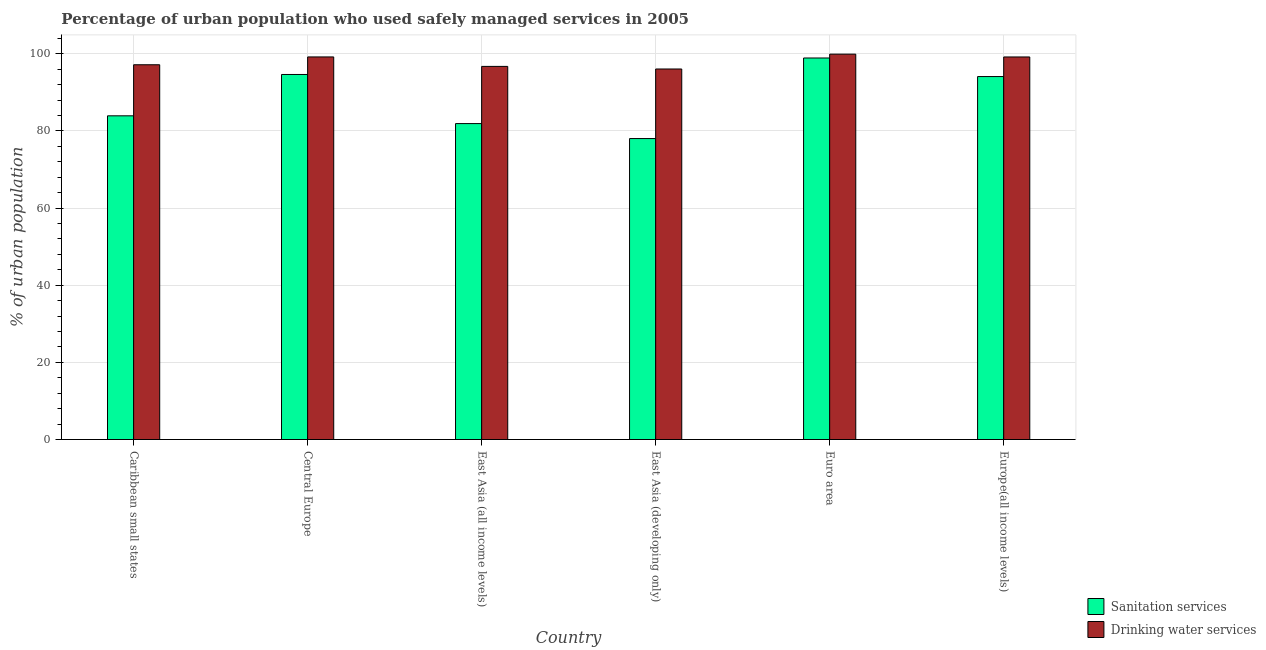Are the number of bars per tick equal to the number of legend labels?
Make the answer very short. Yes. How many bars are there on the 3rd tick from the left?
Provide a succinct answer. 2. How many bars are there on the 5th tick from the right?
Your answer should be very brief. 2. What is the label of the 2nd group of bars from the left?
Your answer should be compact. Central Europe. In how many cases, is the number of bars for a given country not equal to the number of legend labels?
Offer a terse response. 0. What is the percentage of urban population who used drinking water services in Caribbean small states?
Provide a succinct answer. 97.16. Across all countries, what is the maximum percentage of urban population who used sanitation services?
Keep it short and to the point. 98.92. Across all countries, what is the minimum percentage of urban population who used drinking water services?
Give a very brief answer. 96.07. In which country was the percentage of urban population who used drinking water services maximum?
Ensure brevity in your answer.  Euro area. In which country was the percentage of urban population who used sanitation services minimum?
Provide a succinct answer. East Asia (developing only). What is the total percentage of urban population who used drinking water services in the graph?
Your answer should be compact. 588.27. What is the difference between the percentage of urban population who used drinking water services in Central Europe and that in Euro area?
Keep it short and to the point. -0.72. What is the difference between the percentage of urban population who used sanitation services in Europe(all income levels) and the percentage of urban population who used drinking water services in Central Europe?
Your answer should be very brief. -5.09. What is the average percentage of urban population who used sanitation services per country?
Provide a succinct answer. 88.59. What is the difference between the percentage of urban population who used drinking water services and percentage of urban population who used sanitation services in Euro area?
Your answer should be compact. 1. What is the ratio of the percentage of urban population who used drinking water services in Central Europe to that in Europe(all income levels)?
Keep it short and to the point. 1. What is the difference between the highest and the second highest percentage of urban population who used drinking water services?
Offer a very short reply. 0.72. What is the difference between the highest and the lowest percentage of urban population who used drinking water services?
Ensure brevity in your answer.  3.85. What does the 2nd bar from the left in East Asia (all income levels) represents?
Ensure brevity in your answer.  Drinking water services. What does the 2nd bar from the right in East Asia (all income levels) represents?
Make the answer very short. Sanitation services. Are all the bars in the graph horizontal?
Give a very brief answer. No. How many countries are there in the graph?
Make the answer very short. 6. Does the graph contain any zero values?
Your answer should be very brief. No. Does the graph contain grids?
Offer a very short reply. Yes. Where does the legend appear in the graph?
Your response must be concise. Bottom right. What is the title of the graph?
Make the answer very short. Percentage of urban population who used safely managed services in 2005. What is the label or title of the Y-axis?
Offer a very short reply. % of urban population. What is the % of urban population in Sanitation services in Caribbean small states?
Give a very brief answer. 83.93. What is the % of urban population of Drinking water services in Caribbean small states?
Your response must be concise. 97.16. What is the % of urban population in Sanitation services in Central Europe?
Your response must be concise. 94.65. What is the % of urban population of Drinking water services in Central Europe?
Ensure brevity in your answer.  99.19. What is the % of urban population in Sanitation services in East Asia (all income levels)?
Provide a succinct answer. 81.91. What is the % of urban population in Drinking water services in East Asia (all income levels)?
Give a very brief answer. 96.74. What is the % of urban population of Sanitation services in East Asia (developing only)?
Provide a short and direct response. 78.03. What is the % of urban population in Drinking water services in East Asia (developing only)?
Provide a succinct answer. 96.07. What is the % of urban population in Sanitation services in Euro area?
Your answer should be compact. 98.92. What is the % of urban population of Drinking water services in Euro area?
Ensure brevity in your answer.  99.92. What is the % of urban population of Sanitation services in Europe(all income levels)?
Your answer should be compact. 94.11. What is the % of urban population of Drinking water services in Europe(all income levels)?
Your answer should be very brief. 99.19. Across all countries, what is the maximum % of urban population of Sanitation services?
Ensure brevity in your answer.  98.92. Across all countries, what is the maximum % of urban population in Drinking water services?
Ensure brevity in your answer.  99.92. Across all countries, what is the minimum % of urban population in Sanitation services?
Offer a terse response. 78.03. Across all countries, what is the minimum % of urban population of Drinking water services?
Offer a very short reply. 96.07. What is the total % of urban population in Sanitation services in the graph?
Your response must be concise. 531.54. What is the total % of urban population of Drinking water services in the graph?
Keep it short and to the point. 588.27. What is the difference between the % of urban population in Sanitation services in Caribbean small states and that in Central Europe?
Offer a very short reply. -10.72. What is the difference between the % of urban population of Drinking water services in Caribbean small states and that in Central Europe?
Provide a succinct answer. -2.03. What is the difference between the % of urban population in Sanitation services in Caribbean small states and that in East Asia (all income levels)?
Your answer should be very brief. 2.01. What is the difference between the % of urban population in Drinking water services in Caribbean small states and that in East Asia (all income levels)?
Keep it short and to the point. 0.43. What is the difference between the % of urban population in Sanitation services in Caribbean small states and that in East Asia (developing only)?
Your response must be concise. 5.9. What is the difference between the % of urban population of Drinking water services in Caribbean small states and that in East Asia (developing only)?
Keep it short and to the point. 1.1. What is the difference between the % of urban population in Sanitation services in Caribbean small states and that in Euro area?
Make the answer very short. -14.99. What is the difference between the % of urban population of Drinking water services in Caribbean small states and that in Euro area?
Make the answer very short. -2.75. What is the difference between the % of urban population of Sanitation services in Caribbean small states and that in Europe(all income levels)?
Give a very brief answer. -10.18. What is the difference between the % of urban population in Drinking water services in Caribbean small states and that in Europe(all income levels)?
Your answer should be very brief. -2.02. What is the difference between the % of urban population in Sanitation services in Central Europe and that in East Asia (all income levels)?
Give a very brief answer. 12.73. What is the difference between the % of urban population in Drinking water services in Central Europe and that in East Asia (all income levels)?
Keep it short and to the point. 2.45. What is the difference between the % of urban population in Sanitation services in Central Europe and that in East Asia (developing only)?
Give a very brief answer. 16.62. What is the difference between the % of urban population in Drinking water services in Central Europe and that in East Asia (developing only)?
Give a very brief answer. 3.12. What is the difference between the % of urban population in Sanitation services in Central Europe and that in Euro area?
Your answer should be very brief. -4.27. What is the difference between the % of urban population of Drinking water services in Central Europe and that in Euro area?
Provide a succinct answer. -0.72. What is the difference between the % of urban population in Sanitation services in Central Europe and that in Europe(all income levels)?
Your answer should be compact. 0.54. What is the difference between the % of urban population in Drinking water services in Central Europe and that in Europe(all income levels)?
Keep it short and to the point. 0.01. What is the difference between the % of urban population in Sanitation services in East Asia (all income levels) and that in East Asia (developing only)?
Provide a short and direct response. 3.88. What is the difference between the % of urban population in Drinking water services in East Asia (all income levels) and that in East Asia (developing only)?
Offer a terse response. 0.67. What is the difference between the % of urban population in Sanitation services in East Asia (all income levels) and that in Euro area?
Your answer should be compact. -17. What is the difference between the % of urban population of Drinking water services in East Asia (all income levels) and that in Euro area?
Keep it short and to the point. -3.18. What is the difference between the % of urban population of Sanitation services in East Asia (all income levels) and that in Europe(all income levels)?
Make the answer very short. -12.19. What is the difference between the % of urban population in Drinking water services in East Asia (all income levels) and that in Europe(all income levels)?
Your answer should be compact. -2.45. What is the difference between the % of urban population of Sanitation services in East Asia (developing only) and that in Euro area?
Keep it short and to the point. -20.89. What is the difference between the % of urban population of Drinking water services in East Asia (developing only) and that in Euro area?
Keep it short and to the point. -3.85. What is the difference between the % of urban population of Sanitation services in East Asia (developing only) and that in Europe(all income levels)?
Your answer should be very brief. -16.08. What is the difference between the % of urban population of Drinking water services in East Asia (developing only) and that in Europe(all income levels)?
Provide a succinct answer. -3.12. What is the difference between the % of urban population of Sanitation services in Euro area and that in Europe(all income levels)?
Your answer should be very brief. 4.81. What is the difference between the % of urban population in Drinking water services in Euro area and that in Europe(all income levels)?
Offer a terse response. 0.73. What is the difference between the % of urban population of Sanitation services in Caribbean small states and the % of urban population of Drinking water services in Central Europe?
Give a very brief answer. -15.27. What is the difference between the % of urban population in Sanitation services in Caribbean small states and the % of urban population in Drinking water services in East Asia (all income levels)?
Make the answer very short. -12.81. What is the difference between the % of urban population in Sanitation services in Caribbean small states and the % of urban population in Drinking water services in East Asia (developing only)?
Offer a terse response. -12.14. What is the difference between the % of urban population of Sanitation services in Caribbean small states and the % of urban population of Drinking water services in Euro area?
Give a very brief answer. -15.99. What is the difference between the % of urban population of Sanitation services in Caribbean small states and the % of urban population of Drinking water services in Europe(all income levels)?
Offer a very short reply. -15.26. What is the difference between the % of urban population of Sanitation services in Central Europe and the % of urban population of Drinking water services in East Asia (all income levels)?
Your response must be concise. -2.09. What is the difference between the % of urban population in Sanitation services in Central Europe and the % of urban population in Drinking water services in East Asia (developing only)?
Keep it short and to the point. -1.42. What is the difference between the % of urban population of Sanitation services in Central Europe and the % of urban population of Drinking water services in Euro area?
Keep it short and to the point. -5.27. What is the difference between the % of urban population in Sanitation services in Central Europe and the % of urban population in Drinking water services in Europe(all income levels)?
Your response must be concise. -4.54. What is the difference between the % of urban population of Sanitation services in East Asia (all income levels) and the % of urban population of Drinking water services in East Asia (developing only)?
Your response must be concise. -14.16. What is the difference between the % of urban population of Sanitation services in East Asia (all income levels) and the % of urban population of Drinking water services in Euro area?
Your response must be concise. -18. What is the difference between the % of urban population of Sanitation services in East Asia (all income levels) and the % of urban population of Drinking water services in Europe(all income levels)?
Your answer should be very brief. -17.27. What is the difference between the % of urban population of Sanitation services in East Asia (developing only) and the % of urban population of Drinking water services in Euro area?
Make the answer very short. -21.89. What is the difference between the % of urban population in Sanitation services in East Asia (developing only) and the % of urban population in Drinking water services in Europe(all income levels)?
Provide a short and direct response. -21.16. What is the difference between the % of urban population in Sanitation services in Euro area and the % of urban population in Drinking water services in Europe(all income levels)?
Your response must be concise. -0.27. What is the average % of urban population of Sanitation services per country?
Your response must be concise. 88.59. What is the average % of urban population of Drinking water services per country?
Ensure brevity in your answer.  98.04. What is the difference between the % of urban population of Sanitation services and % of urban population of Drinking water services in Caribbean small states?
Keep it short and to the point. -13.24. What is the difference between the % of urban population in Sanitation services and % of urban population in Drinking water services in Central Europe?
Make the answer very short. -4.55. What is the difference between the % of urban population in Sanitation services and % of urban population in Drinking water services in East Asia (all income levels)?
Provide a succinct answer. -14.83. What is the difference between the % of urban population of Sanitation services and % of urban population of Drinking water services in East Asia (developing only)?
Give a very brief answer. -18.04. What is the difference between the % of urban population of Sanitation services and % of urban population of Drinking water services in Euro area?
Ensure brevity in your answer.  -1. What is the difference between the % of urban population of Sanitation services and % of urban population of Drinking water services in Europe(all income levels)?
Your answer should be very brief. -5.08. What is the ratio of the % of urban population in Sanitation services in Caribbean small states to that in Central Europe?
Provide a succinct answer. 0.89. What is the ratio of the % of urban population in Drinking water services in Caribbean small states to that in Central Europe?
Offer a very short reply. 0.98. What is the ratio of the % of urban population of Sanitation services in Caribbean small states to that in East Asia (all income levels)?
Your answer should be very brief. 1.02. What is the ratio of the % of urban population of Drinking water services in Caribbean small states to that in East Asia (all income levels)?
Provide a short and direct response. 1. What is the ratio of the % of urban population of Sanitation services in Caribbean small states to that in East Asia (developing only)?
Ensure brevity in your answer.  1.08. What is the ratio of the % of urban population in Drinking water services in Caribbean small states to that in East Asia (developing only)?
Keep it short and to the point. 1.01. What is the ratio of the % of urban population of Sanitation services in Caribbean small states to that in Euro area?
Provide a short and direct response. 0.85. What is the ratio of the % of urban population of Drinking water services in Caribbean small states to that in Euro area?
Your answer should be compact. 0.97. What is the ratio of the % of urban population of Sanitation services in Caribbean small states to that in Europe(all income levels)?
Make the answer very short. 0.89. What is the ratio of the % of urban population of Drinking water services in Caribbean small states to that in Europe(all income levels)?
Give a very brief answer. 0.98. What is the ratio of the % of urban population in Sanitation services in Central Europe to that in East Asia (all income levels)?
Keep it short and to the point. 1.16. What is the ratio of the % of urban population in Drinking water services in Central Europe to that in East Asia (all income levels)?
Ensure brevity in your answer.  1.03. What is the ratio of the % of urban population in Sanitation services in Central Europe to that in East Asia (developing only)?
Your answer should be compact. 1.21. What is the ratio of the % of urban population in Drinking water services in Central Europe to that in East Asia (developing only)?
Your answer should be very brief. 1.03. What is the ratio of the % of urban population of Sanitation services in Central Europe to that in Euro area?
Provide a short and direct response. 0.96. What is the ratio of the % of urban population of Drinking water services in Central Europe to that in Euro area?
Ensure brevity in your answer.  0.99. What is the ratio of the % of urban population of Drinking water services in Central Europe to that in Europe(all income levels)?
Your response must be concise. 1. What is the ratio of the % of urban population in Sanitation services in East Asia (all income levels) to that in East Asia (developing only)?
Your answer should be compact. 1.05. What is the ratio of the % of urban population in Sanitation services in East Asia (all income levels) to that in Euro area?
Offer a terse response. 0.83. What is the ratio of the % of urban population of Drinking water services in East Asia (all income levels) to that in Euro area?
Give a very brief answer. 0.97. What is the ratio of the % of urban population in Sanitation services in East Asia (all income levels) to that in Europe(all income levels)?
Your answer should be compact. 0.87. What is the ratio of the % of urban population of Drinking water services in East Asia (all income levels) to that in Europe(all income levels)?
Keep it short and to the point. 0.98. What is the ratio of the % of urban population in Sanitation services in East Asia (developing only) to that in Euro area?
Make the answer very short. 0.79. What is the ratio of the % of urban population of Drinking water services in East Asia (developing only) to that in Euro area?
Give a very brief answer. 0.96. What is the ratio of the % of urban population in Sanitation services in East Asia (developing only) to that in Europe(all income levels)?
Your answer should be compact. 0.83. What is the ratio of the % of urban population in Drinking water services in East Asia (developing only) to that in Europe(all income levels)?
Provide a short and direct response. 0.97. What is the ratio of the % of urban population in Sanitation services in Euro area to that in Europe(all income levels)?
Provide a short and direct response. 1.05. What is the ratio of the % of urban population of Drinking water services in Euro area to that in Europe(all income levels)?
Provide a succinct answer. 1.01. What is the difference between the highest and the second highest % of urban population in Sanitation services?
Your response must be concise. 4.27. What is the difference between the highest and the second highest % of urban population in Drinking water services?
Your response must be concise. 0.72. What is the difference between the highest and the lowest % of urban population of Sanitation services?
Your answer should be compact. 20.89. What is the difference between the highest and the lowest % of urban population of Drinking water services?
Your answer should be compact. 3.85. 